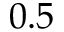Convert formula to latex. <formula><loc_0><loc_0><loc_500><loc_500>0 . 5</formula> 